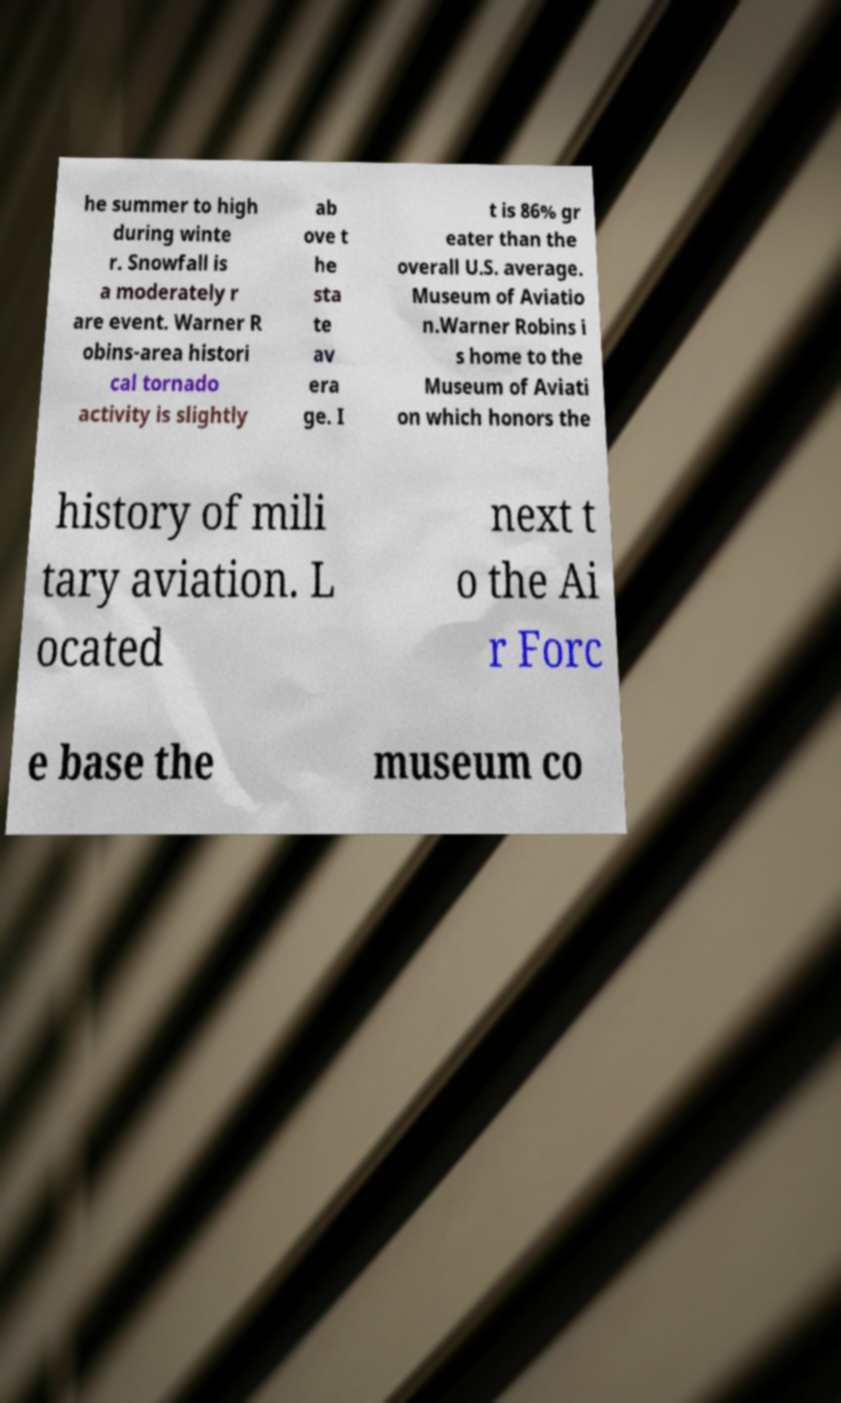I need the written content from this picture converted into text. Can you do that? he summer to high during winte r. Snowfall is a moderately r are event. Warner R obins-area histori cal tornado activity is slightly ab ove t he sta te av era ge. I t is 86% gr eater than the overall U.S. average. Museum of Aviatio n.Warner Robins i s home to the Museum of Aviati on which honors the history of mili tary aviation. L ocated next t o the Ai r Forc e base the museum co 